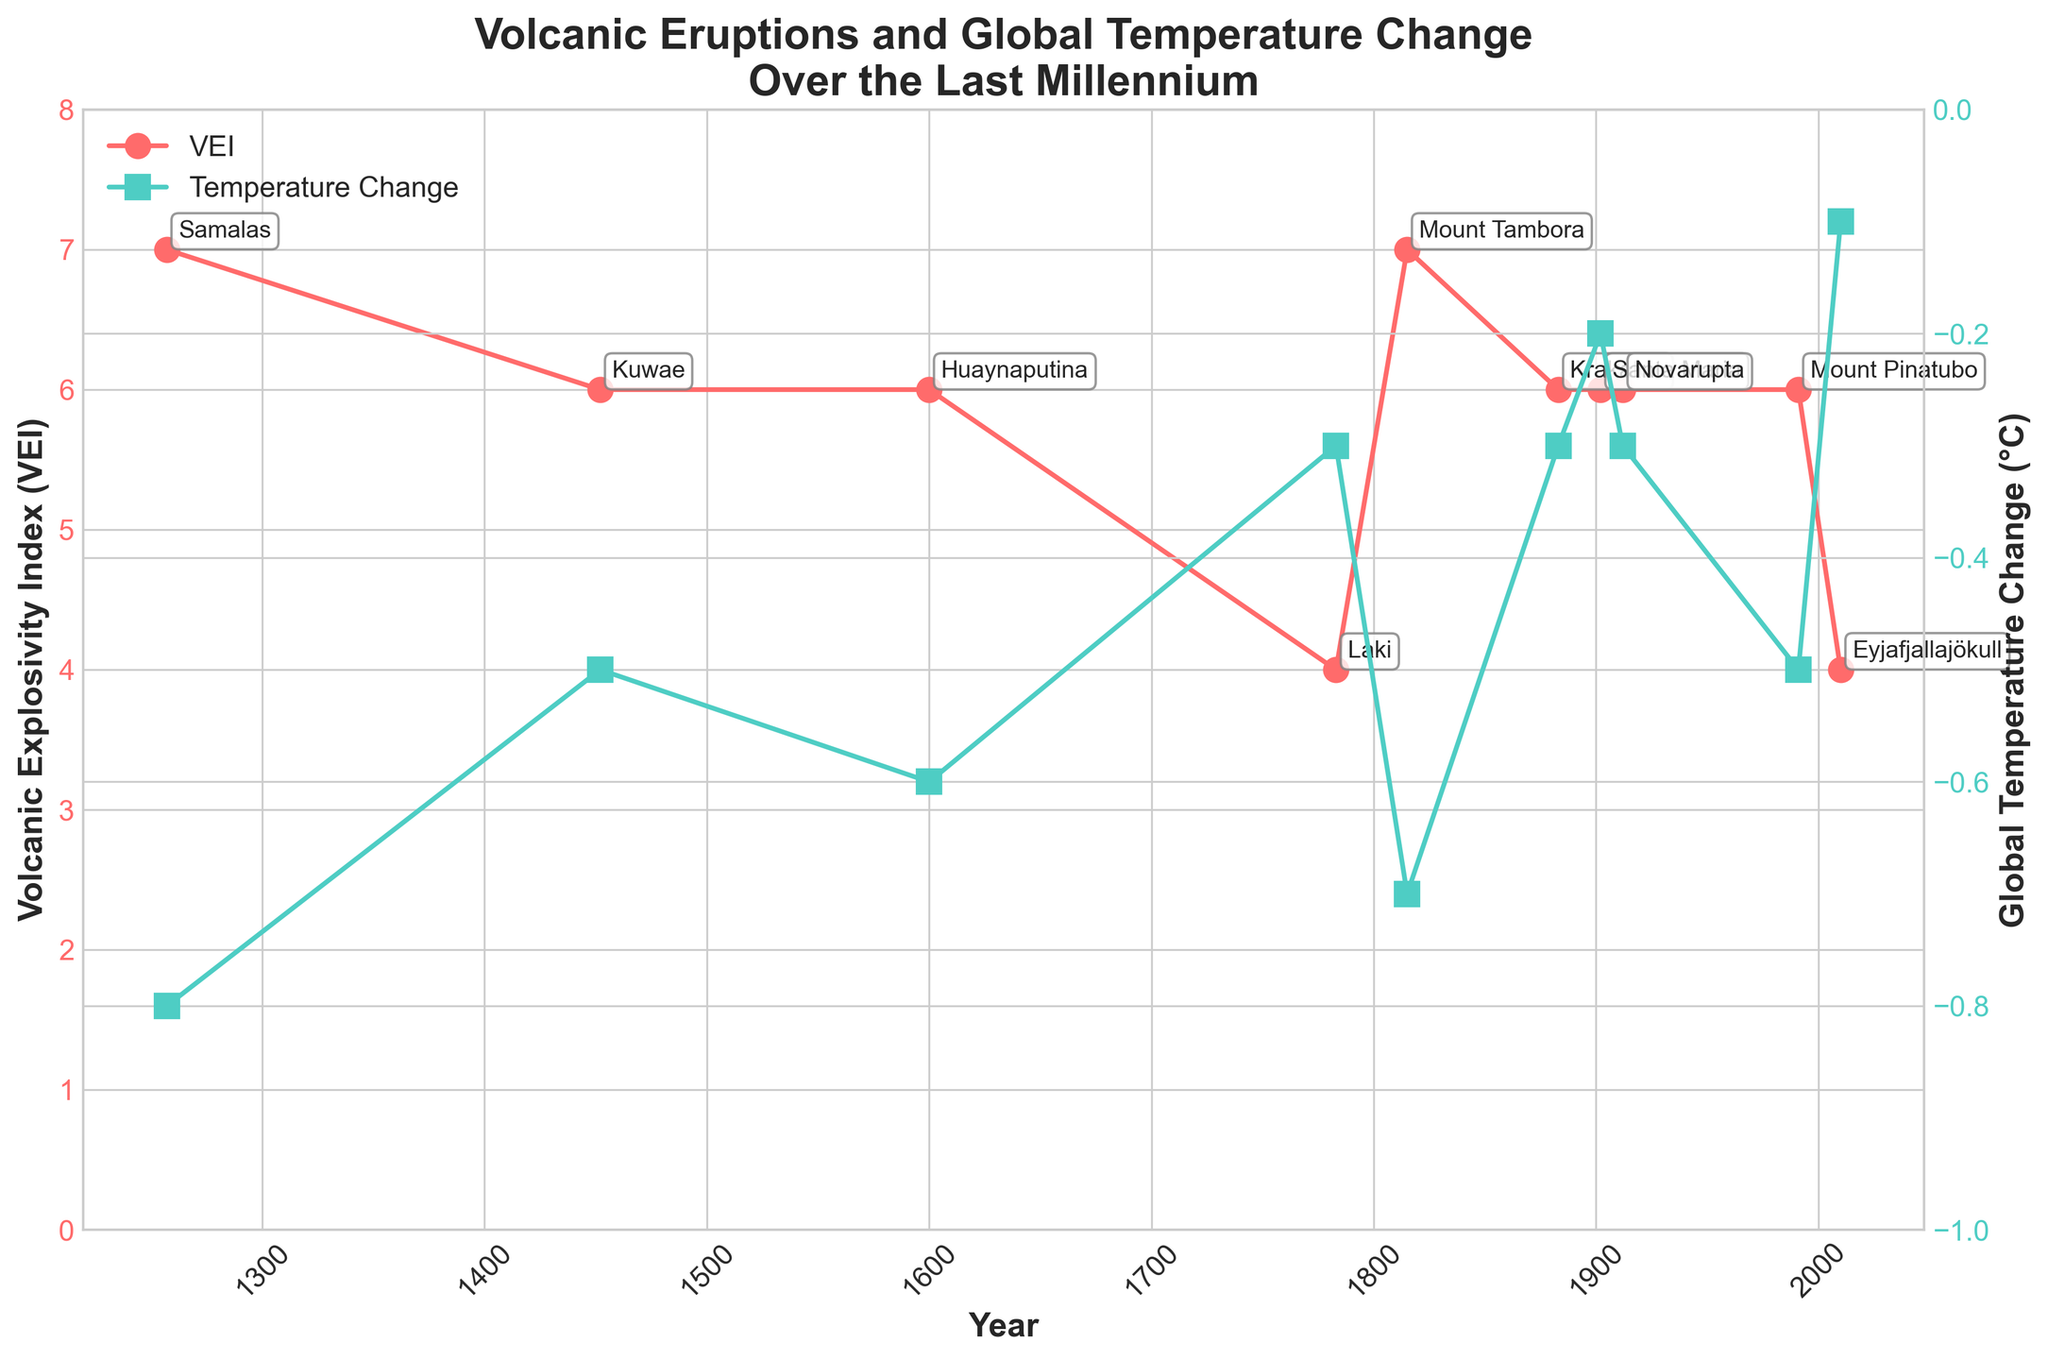Which eruption had the highest Volcanic Explosivity Index (VEI) and in what year did it occur? The highest VEI on the plot is 7. Looking at the peaks, there are two eruptions with this VEI: Samalas in 1257 and Mount Tambora in 1815.
Answer: Samalas in 1257 and Mount Tambora in 1815 What is the average Global Temperature Change (°C) caused by the eruptions? Adding up all the global temperature changes: (-0.8) + (-0.5) + (-0.6) + (-0.3) + (-0.7) + (-0.3) + (-0.2) + (-0.3) + (-0.5) + (-0.1) = -4.3, then divide by 10 (number of eruptions): -4.3 / 10 = -0.43
Answer: -0.43 Which eruption had a Volcanic Explosivity Index (VEI) of 4 and what was its Global Temperature Change (°C)? The plot shows two points with a VEI of 4: Laki in 1783 and Eyjafjallajökull in 2010. The global temperature changes for these are -0.3°C and -0.1°C respectively.
Answer: Laki -0.3°C, Eyjafjallajökull -0.1°C How many eruptions resulted in a Global Temperature Change (°C) of less than -0.5°C? The plot has two y-axis lines for Global Temperature Change. Points below -0.5°C are: Samalas 1257 (-0.8°C), Huaynaputina 1600 (-0.6°C), and Mount Tambora 1815 (-0.7°C).
Answer: 3 Which eruption had the smallest impact on Global Temperature Change (°C), and what was its VEI? The smallest impact on Global Temperature Change is shown by Eyjafjallajökull in 2010 with -0.1°C. Its VEI is 4.
Answer: Eyjafjallajökull, VEI 4 Which event caused the most significant drop in global temperature, and what was its VEI? Referring to the second y-axis, the event with the largest drop in global temperature is Samalas in 1257 with -0.8°C. Its VEI is 7.
Answer: Samalas, VEI 7 Compare the eruptions of Krakatoa and Mount Pinatubo. Which had a more significant impact on global temperature, and how do their VEIs compare? Krakatoa (1883) caused a -0.3°C change, while Mount Pinatubo (1991) caused a -0.5°C change. Both eruptions had a VEI of 6. Thus, Mount Pinatubo had a more significant impact on temperature.
Answer: Mount Pinatubo had a greater impact, both VEI 6 During which century did the most significant number of high VEI eruptions (6 or more) occur? The high VEI eruptions (6 or more) are in: 1257, 1452, 1600, 1815, 1883, 1902, 1912, and 1991. The 19th century (1800s) and the 20th century (1900s) each have 3 eruptions.
Answer: 19th and 20th centuries 